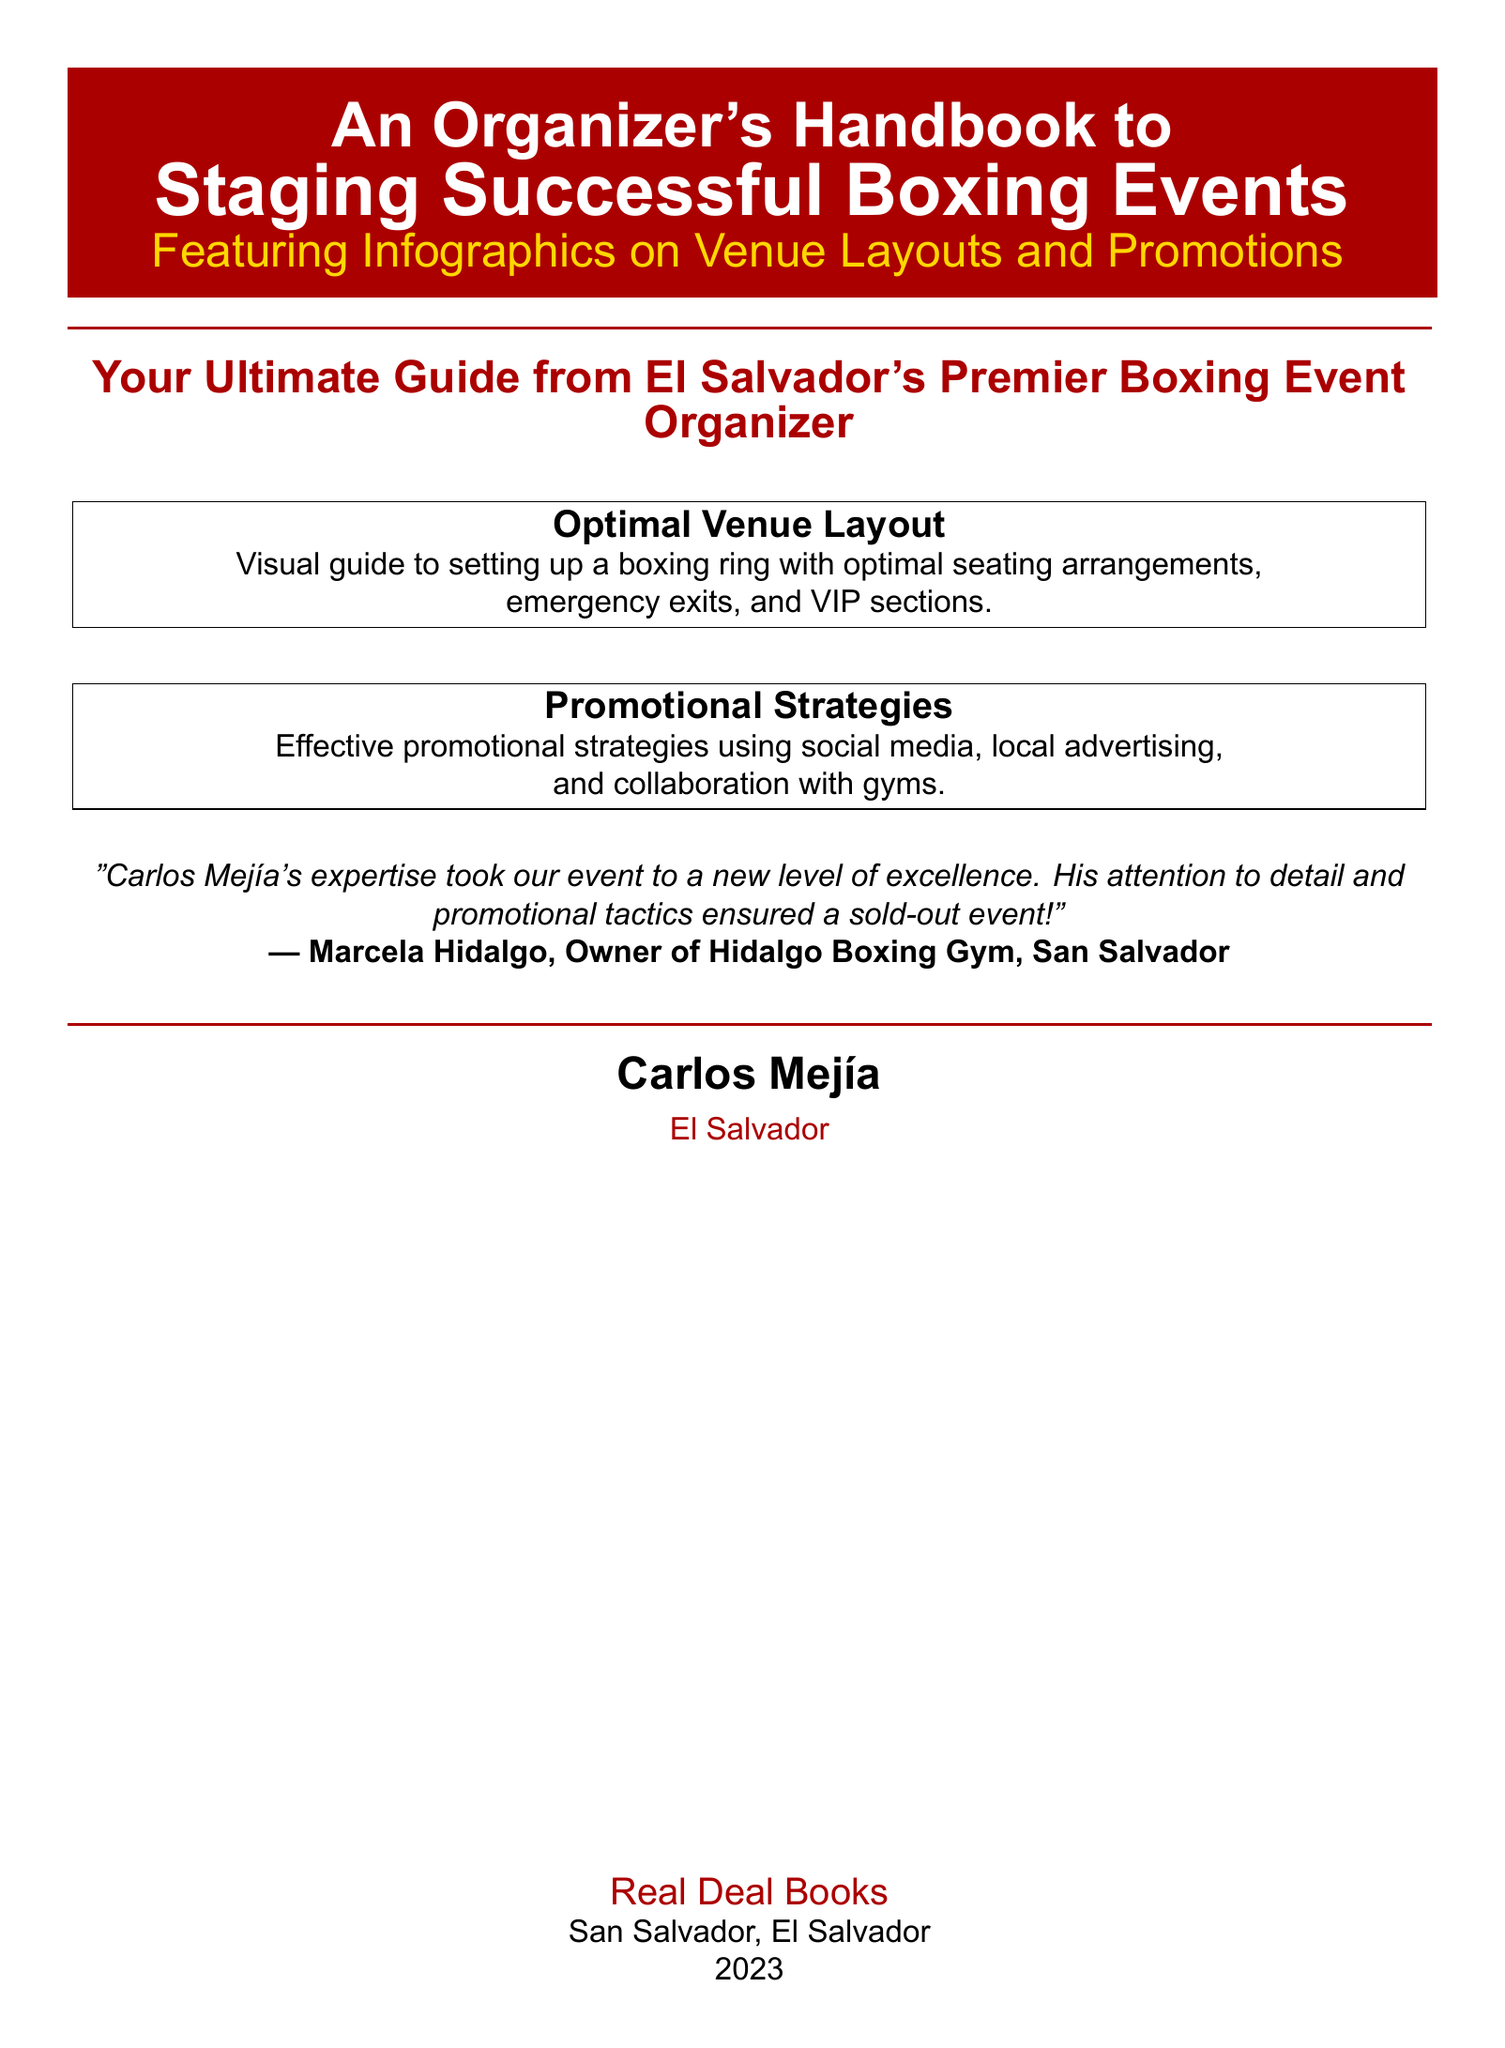What is the title of the handbook? The title appears prominently at the top of the document and reads "An Organizer's Handbook to Staging Successful Boxing Events."
Answer: An Organizer's Handbook to Staging Successful Boxing Events Who is the author of the book? The author's name is mentioned at the bottom of the document, signifying the creator of this handbook.
Answer: Carlos Mejía What year was this book published? The publication year is indicated towards the bottom of the document.
Answer: 2023 What color is used for the background of the title box? The document includes a specific color used in the title box, which can be found in the color settings defined within the document.
Answer: Red What is one promotional strategy mentioned in the handbook? The promotional strategies are detailed in a dedicated section of the document, offering insight on effective tactics.
Answer: Social media What is the main focus of the infographics featured in the book? The infographics are specified to cover certain topics primarily relating to event organization, which is outlined in the document.
Answer: Venue Layouts and Promotions How does Marcela Hidalgo describe Carlos Mejía's expertise? A quote attributed to Marcela Hidalgo provides insight into her perspective on Mejía’s professional skills.
Answer: New level of excellence Where is the author based? The location of the author is stated towards the bottom section of the document, providing geographical context.
Answer: El Salvador What is the focal point of the illustrated optimal venue layout? The handbook indicates a specific setup that emphasizes a critical component of boxing events, as outlined in the relevant section.
Answer: Boxing ring 